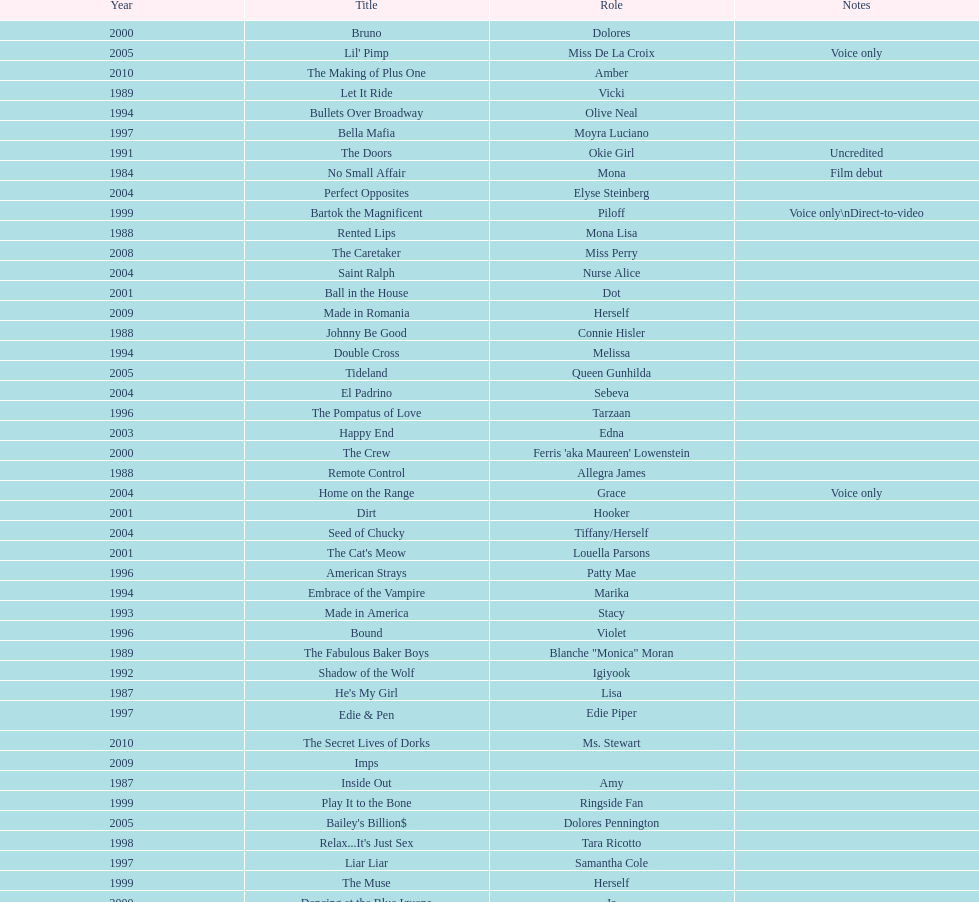Which movie was also a film debut? No Small Affair. 